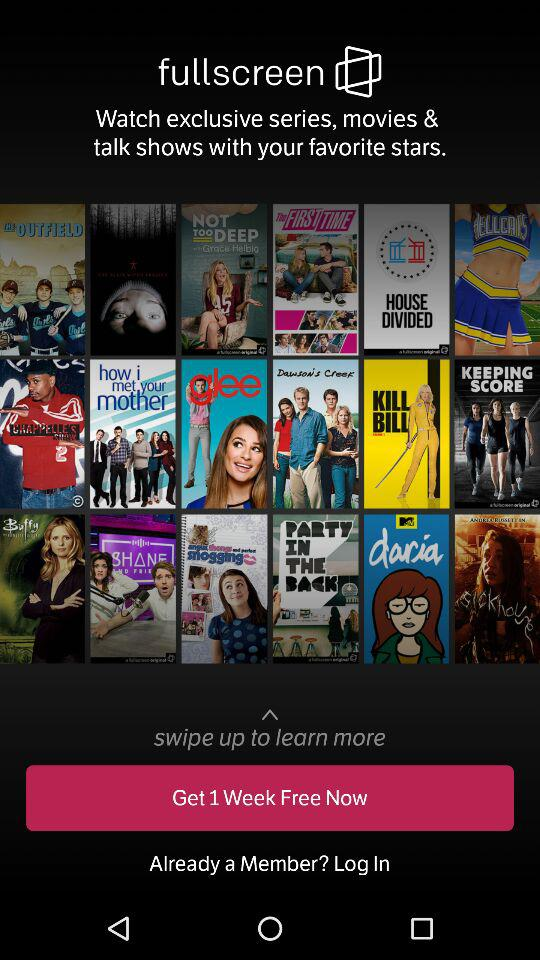How many rows of items are there in total?
Answer the question using a single word or phrase. 3 